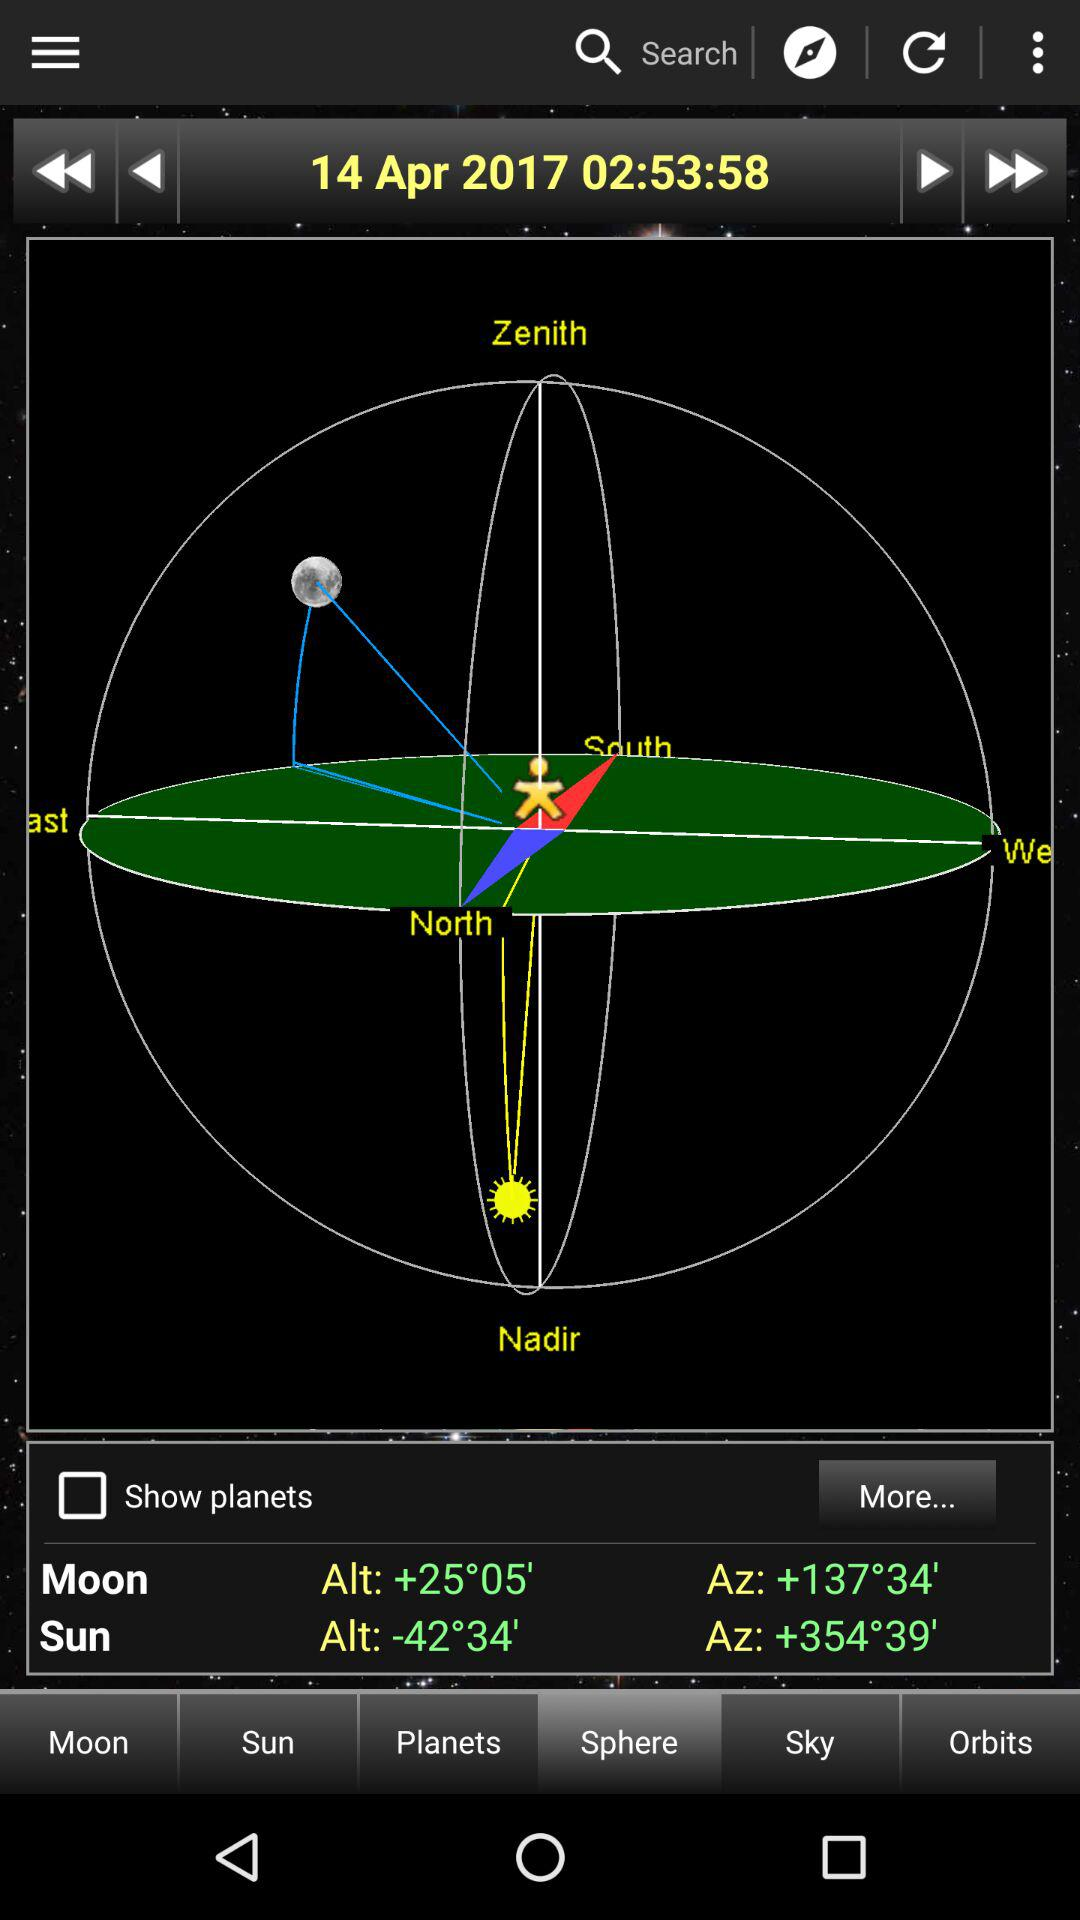How much greater is the altitude of the Sun than the Moon?
Answer the question using a single word or phrase. 67°39' 